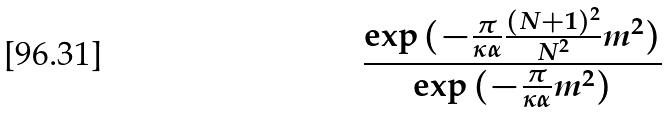Convert formula to latex. <formula><loc_0><loc_0><loc_500><loc_500>\frac { \exp { ( - \frac { \pi } { \kappa \alpha } \frac { ( N + 1 ) ^ { 2 } } { N ^ { 2 } } m ^ { 2 } ) } } { \exp { ( - \frac { \pi } { \kappa \alpha } m ^ { 2 } } ) }</formula> 